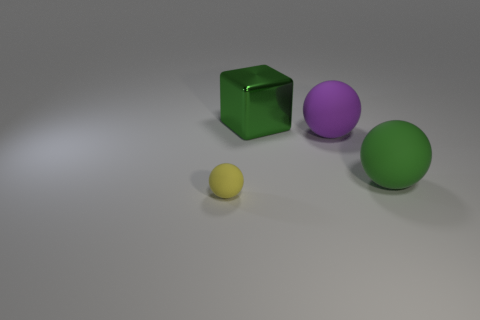Add 1 large blue rubber cylinders. How many objects exist? 5 Subtract all balls. How many objects are left? 1 Subtract all green cubes. Subtract all tiny yellow spheres. How many objects are left? 2 Add 4 large purple rubber balls. How many large purple rubber balls are left? 5 Add 4 green metallic blocks. How many green metallic blocks exist? 5 Subtract 0 green cylinders. How many objects are left? 4 